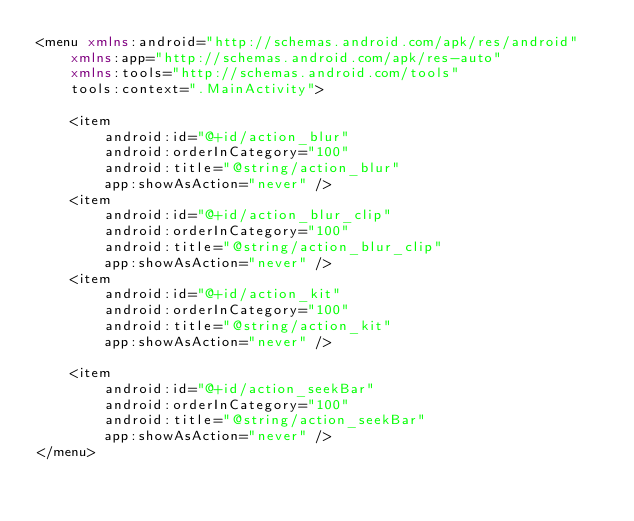<code> <loc_0><loc_0><loc_500><loc_500><_XML_><menu xmlns:android="http://schemas.android.com/apk/res/android"
    xmlns:app="http://schemas.android.com/apk/res-auto"
    xmlns:tools="http://schemas.android.com/tools"
    tools:context=".MainActivity">

    <item
        android:id="@+id/action_blur"
        android:orderInCategory="100"
        android:title="@string/action_blur"
        app:showAsAction="never" />
    <item
        android:id="@+id/action_blur_clip"
        android:orderInCategory="100"
        android:title="@string/action_blur_clip"
        app:showAsAction="never" />
    <item
        android:id="@+id/action_kit"
        android:orderInCategory="100"
        android:title="@string/action_kit"
        app:showAsAction="never" />

    <item
        android:id="@+id/action_seekBar"
        android:orderInCategory="100"
        android:title="@string/action_seekBar"
        app:showAsAction="never" />
</menu>
</code> 